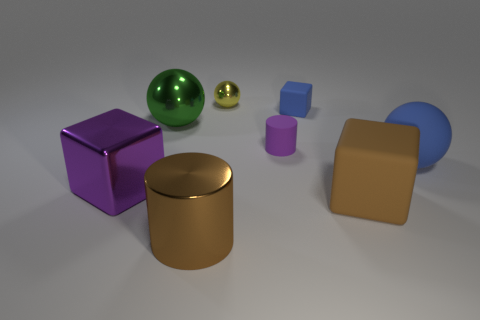Is there a brown object made of the same material as the big green sphere?
Give a very brief answer. Yes. There is a brown thing that is to the right of the purple matte thing; is there a green metal ball that is in front of it?
Your response must be concise. No. There is a brown thing that is on the left side of the brown matte block; what is it made of?
Keep it short and to the point. Metal. Is the tiny yellow thing the same shape as the purple matte thing?
Your answer should be compact. No. What color is the cylinder that is left of the cylinder behind the cube that is on the left side of the small purple matte object?
Provide a succinct answer. Brown. How many brown matte things are the same shape as the big blue matte thing?
Make the answer very short. 0. There is a purple object on the left side of the large brown object that is on the left side of the tiny blue thing; how big is it?
Your answer should be very brief. Large. Does the green metallic ball have the same size as the blue block?
Ensure brevity in your answer.  No. Are there any objects right of the matte block on the right side of the cube that is behind the small purple matte thing?
Offer a very short reply. Yes. The yellow object has what size?
Offer a terse response. Small. 